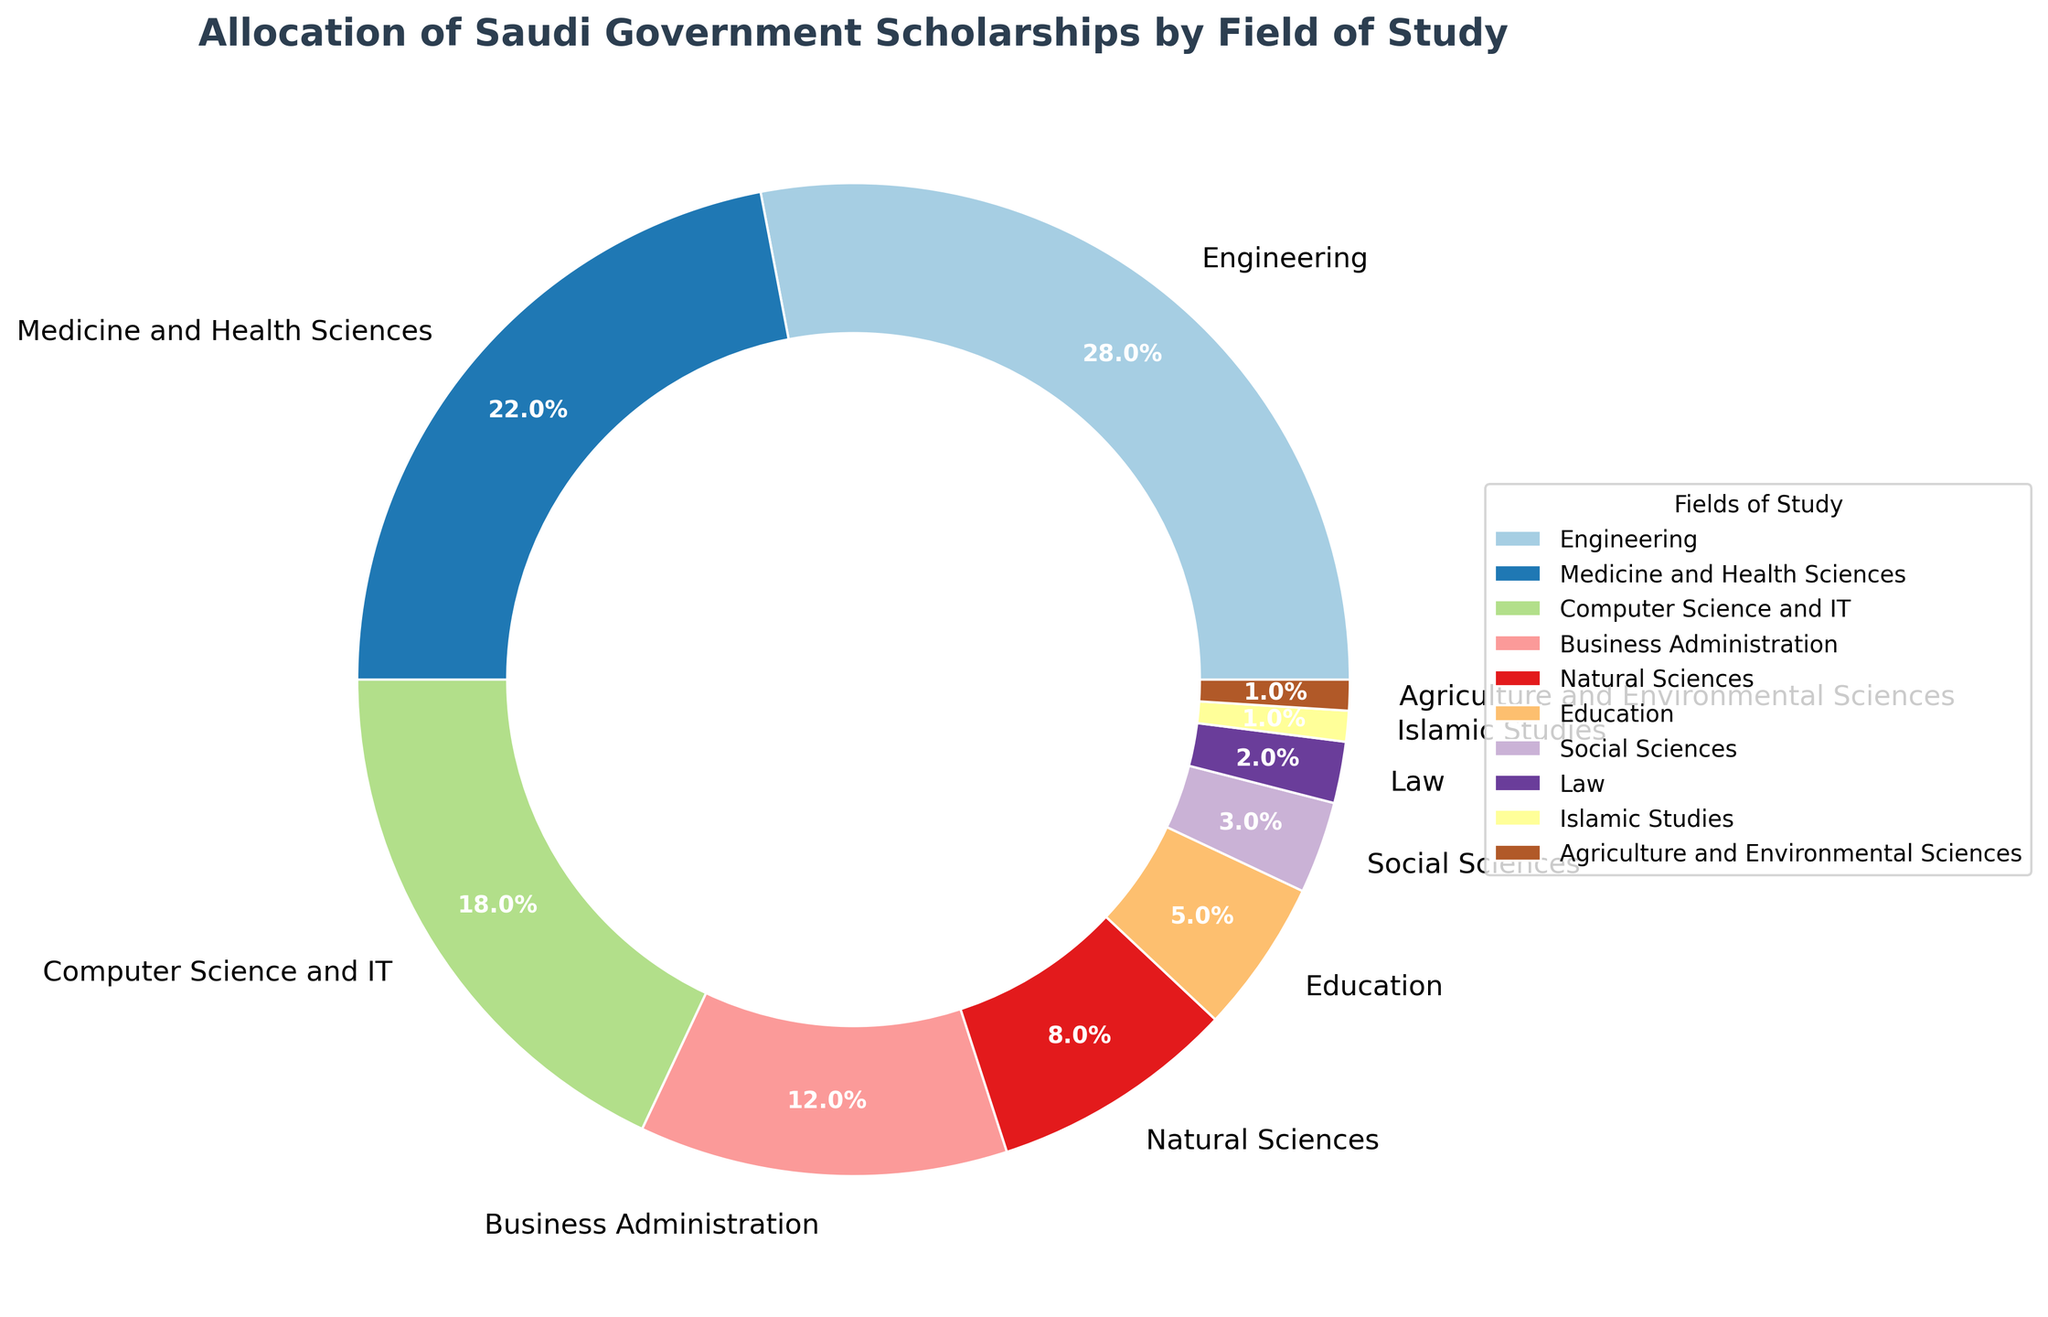what percentage of scholarships is allocated to Business Administration and Natural Sciences combined? The percentage for Business Administration is 12% and for Natural Sciences is 8%. Adding these together gives 12% + 8% = 20%
Answer: 20% what is the difference in scholarship allocation between Engineering and Computer Science and IT? The percentage for Engineering is 28% and for Computer Science and IT is 18%. The difference is found by subtraction: 28% - 18% = 10%
Answer: 10% which field receives more scholarships, Medicine and Health Sciences or Education? Medicine and Health Sciences receives 22% of the scholarships, whereas Education receives 5%. Since 22% is greater than 5%, Medicine and Health Sciences receives more scholarships
Answer: Medicine and Health Sciences how do the allocations for Law and Islamic Studies compare? Law receives 2% of the scholarships while Islamic Studies receives 1%. Comparing these, 2% is greater than 1%
Answer: Law what is the total percentage of scholarships allocated to the fields receiving less than 10% each? The fields receiving less than 10% are Natural Sciences (8%), Education (5%), Social Sciences (3%), Law (2%), Islamic Studies (1%), and Agriculture and Environmental Sciences (1%). Summing these percentages gives 8% + 5% + 3% + 2% + 1% + 1% = 20%
Answer: 20% what fields receive the smallest and largest allocation of scholarships, respectively? The field with the largest allocation is Engineering at 28%, and the fields with the smallest allocation are Islamic Studies and Agriculture and Environmental Sciences, each at 1%
Answer: Engineering, Islamic Studies and Agriculture and Environmental Sciences what percentage of scholarships is allocated to fields related to sciences (Natural Sciences, Medicine and Health Sciences, Computer Science and IT)? Natural Sciences has 8%, Medicine and Health Sciences has 22%, and Computer Science and IT has 18%. Summing these gives 8% + 22% + 18% = 48%
Answer: 48% is the allocation for Social Sciences more than or less than half the allocation for Business Administration? The allocation for Social Sciences is 3%, and half of the allocation for Business Administration (which is 12%) is 6%. Since 3% is less than 6%, the allocation for Social Sciences is less than half of that for Business Administration
Answer: Less than what is the total percentage allocated to the top two fields? The top two fields are Engineering (28%) and Medicine and Health Sciences (22%). Adding these together gives 28% + 22% = 50%
Answer: 50% 